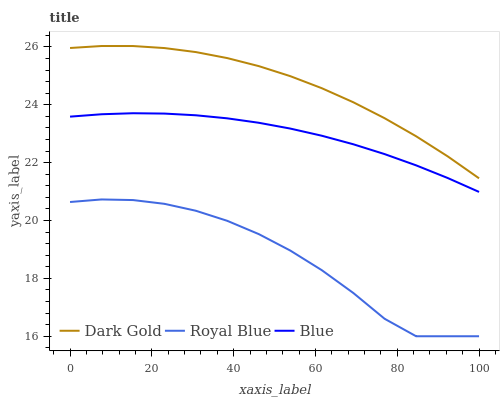Does Dark Gold have the minimum area under the curve?
Answer yes or no. No. Does Royal Blue have the maximum area under the curve?
Answer yes or no. No. Is Dark Gold the smoothest?
Answer yes or no. No. Is Dark Gold the roughest?
Answer yes or no. No. Does Dark Gold have the lowest value?
Answer yes or no. No. Does Royal Blue have the highest value?
Answer yes or no. No. Is Blue less than Dark Gold?
Answer yes or no. Yes. Is Dark Gold greater than Blue?
Answer yes or no. Yes. Does Blue intersect Dark Gold?
Answer yes or no. No. 